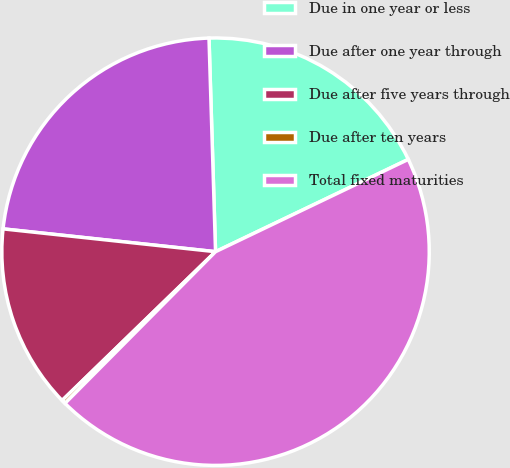Convert chart. <chart><loc_0><loc_0><loc_500><loc_500><pie_chart><fcel>Due in one year or less<fcel>Due after one year through<fcel>Due after five years through<fcel>Due after ten years<fcel>Total fixed maturities<nl><fcel>18.38%<fcel>22.81%<fcel>13.96%<fcel>0.3%<fcel>44.55%<nl></chart> 